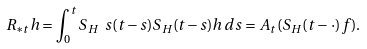Convert formula to latex. <formula><loc_0><loc_0><loc_500><loc_500>R _ { \ast t } h = \int ^ { t } _ { 0 } S _ { H } \ s ( t - s ) S _ { H } ( t - s ) h \, d s = A _ { t } ( S _ { H } ( t - \, \cdot ) f ) .</formula> 